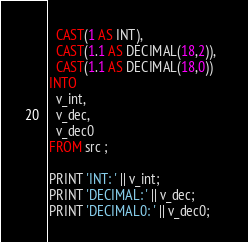Convert code to text. <code><loc_0><loc_0><loc_500><loc_500><_SQL_>  CAST(1 AS INT), 
  CAST(1.1 AS DECIMAL(18,2)),
  CAST(1.1 AS DECIMAL(18,0))   
INTO 
  v_int,
  v_dec,
  v_dec0  
FROM src ;
        
PRINT 'INT: ' || v_int;
PRINT 'DECIMAL: ' || v_dec;
PRINT 'DECIMAL0: ' || v_dec0;</code> 